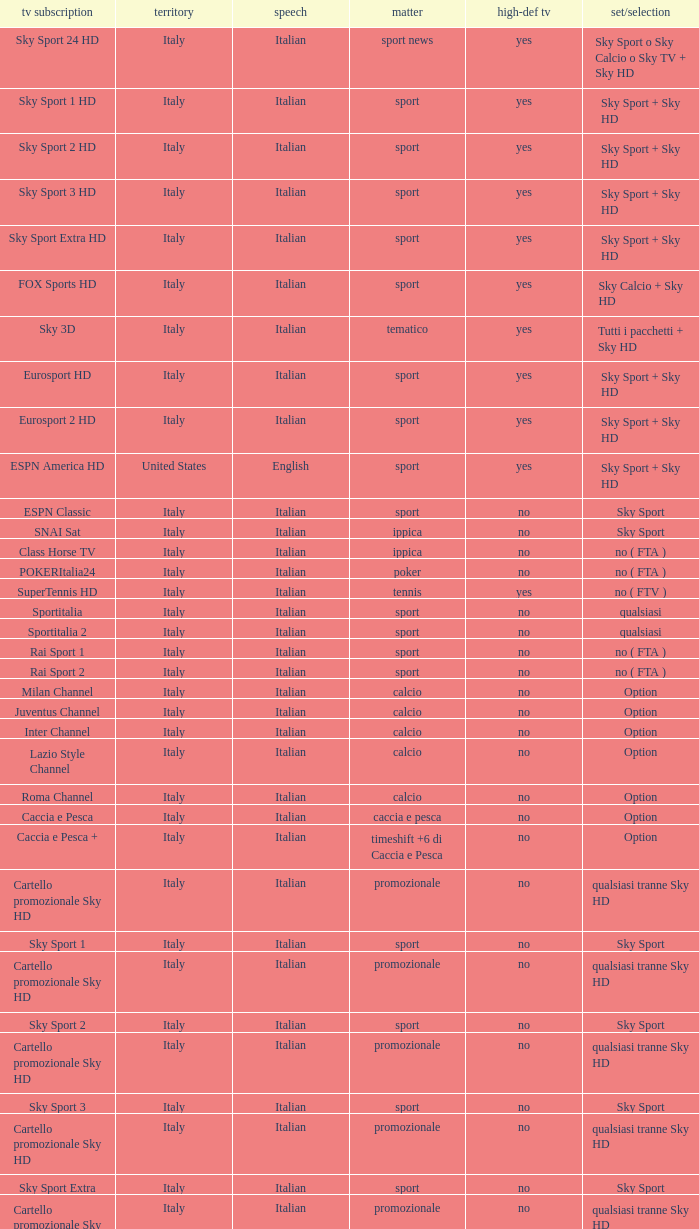What is Country, when Television Service is Eurosport 2? Italy. Parse the table in full. {'header': ['tv subscription', 'territory', 'speech', 'matter', 'high-def tv', 'set/selection'], 'rows': [['Sky Sport 24 HD', 'Italy', 'Italian', 'sport news', 'yes', 'Sky Sport o Sky Calcio o Sky TV + Sky HD'], ['Sky Sport 1 HD', 'Italy', 'Italian', 'sport', 'yes', 'Sky Sport + Sky HD'], ['Sky Sport 2 HD', 'Italy', 'Italian', 'sport', 'yes', 'Sky Sport + Sky HD'], ['Sky Sport 3 HD', 'Italy', 'Italian', 'sport', 'yes', 'Sky Sport + Sky HD'], ['Sky Sport Extra HD', 'Italy', 'Italian', 'sport', 'yes', 'Sky Sport + Sky HD'], ['FOX Sports HD', 'Italy', 'Italian', 'sport', 'yes', 'Sky Calcio + Sky HD'], ['Sky 3D', 'Italy', 'Italian', 'tematico', 'yes', 'Tutti i pacchetti + Sky HD'], ['Eurosport HD', 'Italy', 'Italian', 'sport', 'yes', 'Sky Sport + Sky HD'], ['Eurosport 2 HD', 'Italy', 'Italian', 'sport', 'yes', 'Sky Sport + Sky HD'], ['ESPN America HD', 'United States', 'English', 'sport', 'yes', 'Sky Sport + Sky HD'], ['ESPN Classic', 'Italy', 'Italian', 'sport', 'no', 'Sky Sport'], ['SNAI Sat', 'Italy', 'Italian', 'ippica', 'no', 'Sky Sport'], ['Class Horse TV', 'Italy', 'Italian', 'ippica', 'no', 'no ( FTA )'], ['POKERItalia24', 'Italy', 'Italian', 'poker', 'no', 'no ( FTA )'], ['SuperTennis HD', 'Italy', 'Italian', 'tennis', 'yes', 'no ( FTV )'], ['Sportitalia', 'Italy', 'Italian', 'sport', 'no', 'qualsiasi'], ['Sportitalia 2', 'Italy', 'Italian', 'sport', 'no', 'qualsiasi'], ['Rai Sport 1', 'Italy', 'Italian', 'sport', 'no', 'no ( FTA )'], ['Rai Sport 2', 'Italy', 'Italian', 'sport', 'no', 'no ( FTA )'], ['Milan Channel', 'Italy', 'Italian', 'calcio', 'no', 'Option'], ['Juventus Channel', 'Italy', 'Italian', 'calcio', 'no', 'Option'], ['Inter Channel', 'Italy', 'Italian', 'calcio', 'no', 'Option'], ['Lazio Style Channel', 'Italy', 'Italian', 'calcio', 'no', 'Option'], ['Roma Channel', 'Italy', 'Italian', 'calcio', 'no', 'Option'], ['Caccia e Pesca', 'Italy', 'Italian', 'caccia e pesca', 'no', 'Option'], ['Caccia e Pesca +', 'Italy', 'Italian', 'timeshift +6 di Caccia e Pesca', 'no', 'Option'], ['Cartello promozionale Sky HD', 'Italy', 'Italian', 'promozionale', 'no', 'qualsiasi tranne Sky HD'], ['Sky Sport 1', 'Italy', 'Italian', 'sport', 'no', 'Sky Sport'], ['Cartello promozionale Sky HD', 'Italy', 'Italian', 'promozionale', 'no', 'qualsiasi tranne Sky HD'], ['Sky Sport 2', 'Italy', 'Italian', 'sport', 'no', 'Sky Sport'], ['Cartello promozionale Sky HD', 'Italy', 'Italian', 'promozionale', 'no', 'qualsiasi tranne Sky HD'], ['Sky Sport 3', 'Italy', 'Italian', 'sport', 'no', 'Sky Sport'], ['Cartello promozionale Sky HD', 'Italy', 'Italian', 'promozionale', 'no', 'qualsiasi tranne Sky HD'], ['Sky Sport Extra', 'Italy', 'Italian', 'sport', 'no', 'Sky Sport'], ['Cartello promozionale Sky HD', 'Italy', 'Italian', 'promozionale', 'no', 'qualsiasi tranne Sky HD'], ['Sky Supercalcio', 'Italy', 'Italian', 'calcio', 'no', 'Sky Calcio'], ['Cartello promozionale Sky HD', 'Italy', 'Italian', 'promozionale', 'no', 'qualsiasi tranne Sky HD'], ['Eurosport', 'Italy', 'Italian', 'sport', 'no', 'Sky Sport'], ['Eurosport 2', 'Italy', 'Italian', 'sport', 'no', 'Sky Sport'], ['ESPN America', 'Italy', 'Italian', 'sport', 'no', 'Sky Sport']]} 